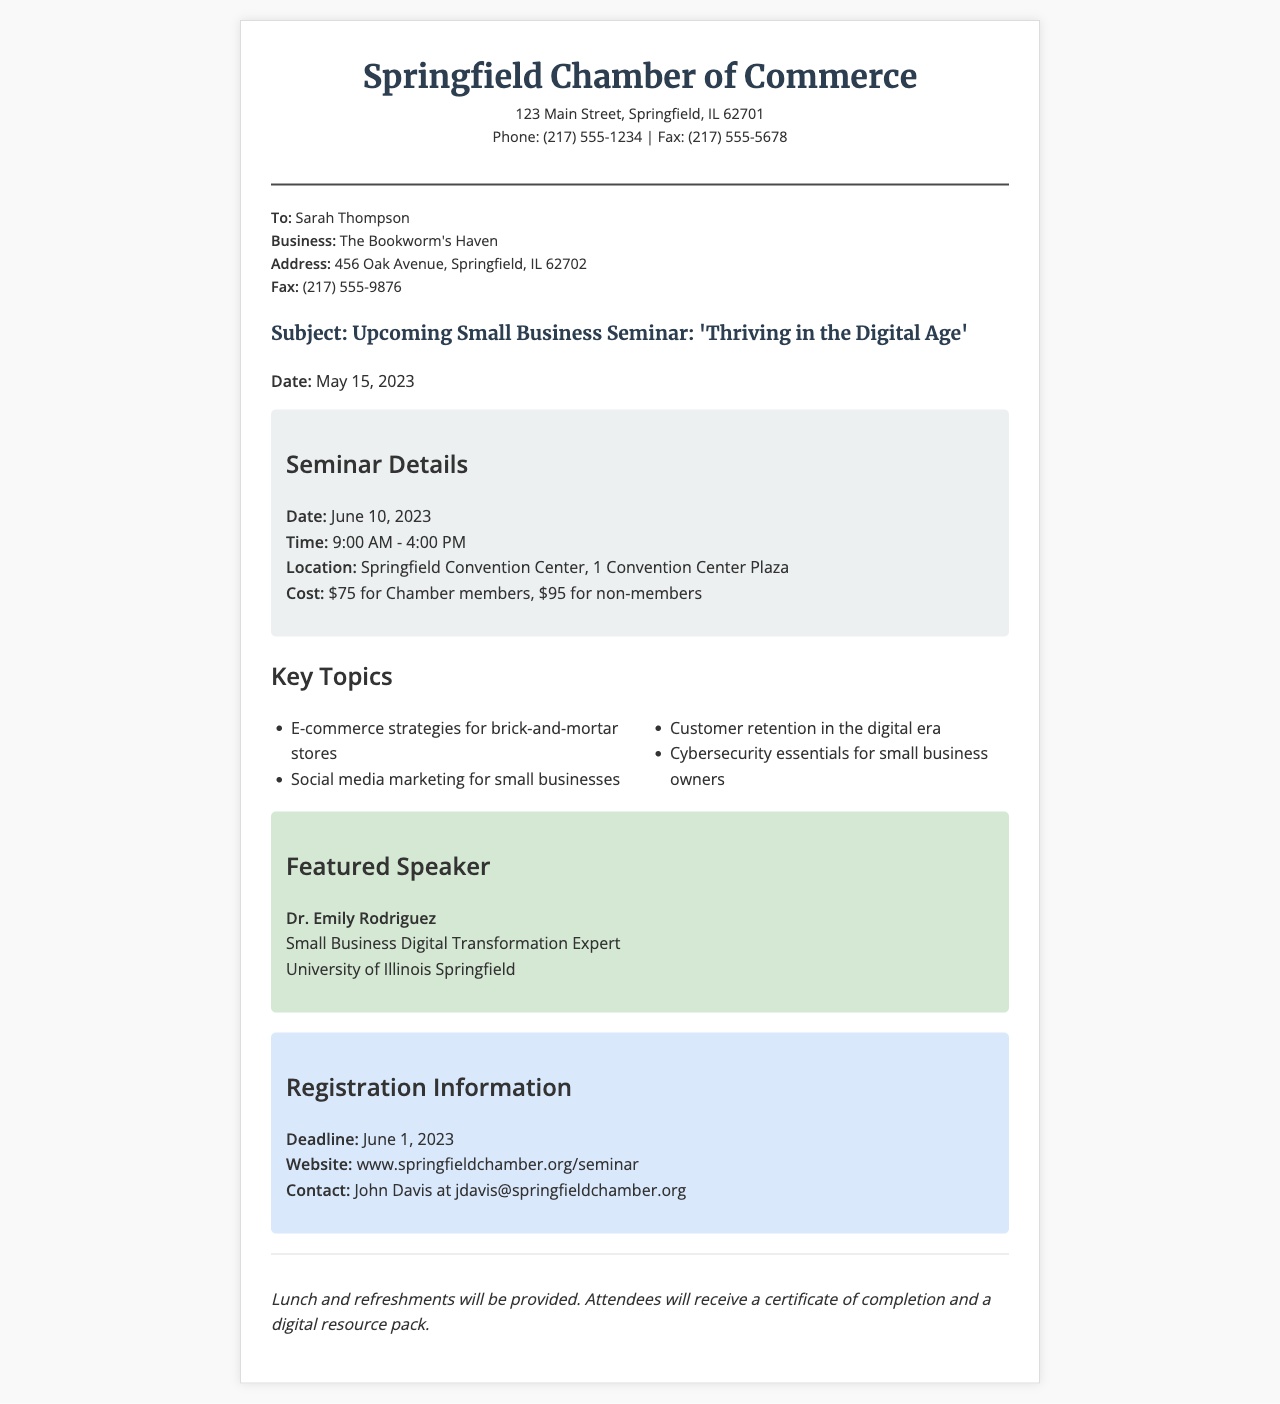what is the name of the seminar? The name of the seminar is mentioned in the subject line of the document.
Answer: 'Thriving in the Digital Age' what is the date of the seminar? The date of the seminar is specified in the seminar details section.
Answer: June 10, 2023 who is the featured speaker? The featured speaker's name is given in the featured speaker section of the document.
Answer: Dr. Emily Rodriguez what is the location of the seminar? The location is provided in the seminar details section.
Answer: Springfield Convention Center, 1 Convention Center Plaza how much does it cost for non-members? The cost for non-members is indicated in the seminar details section.
Answer: $95 what is the registration deadline? The registration deadline is provided in the registration information section.
Answer: June 1, 2023 what is included for attendees? The information about what attendees will receive is mentioned at the end of the document.
Answer: Certificate of completion and a digital resource pack what topic covers customer retention? The specific topic about customer retention is noted in the key topics list.
Answer: Customer retention in the digital era 